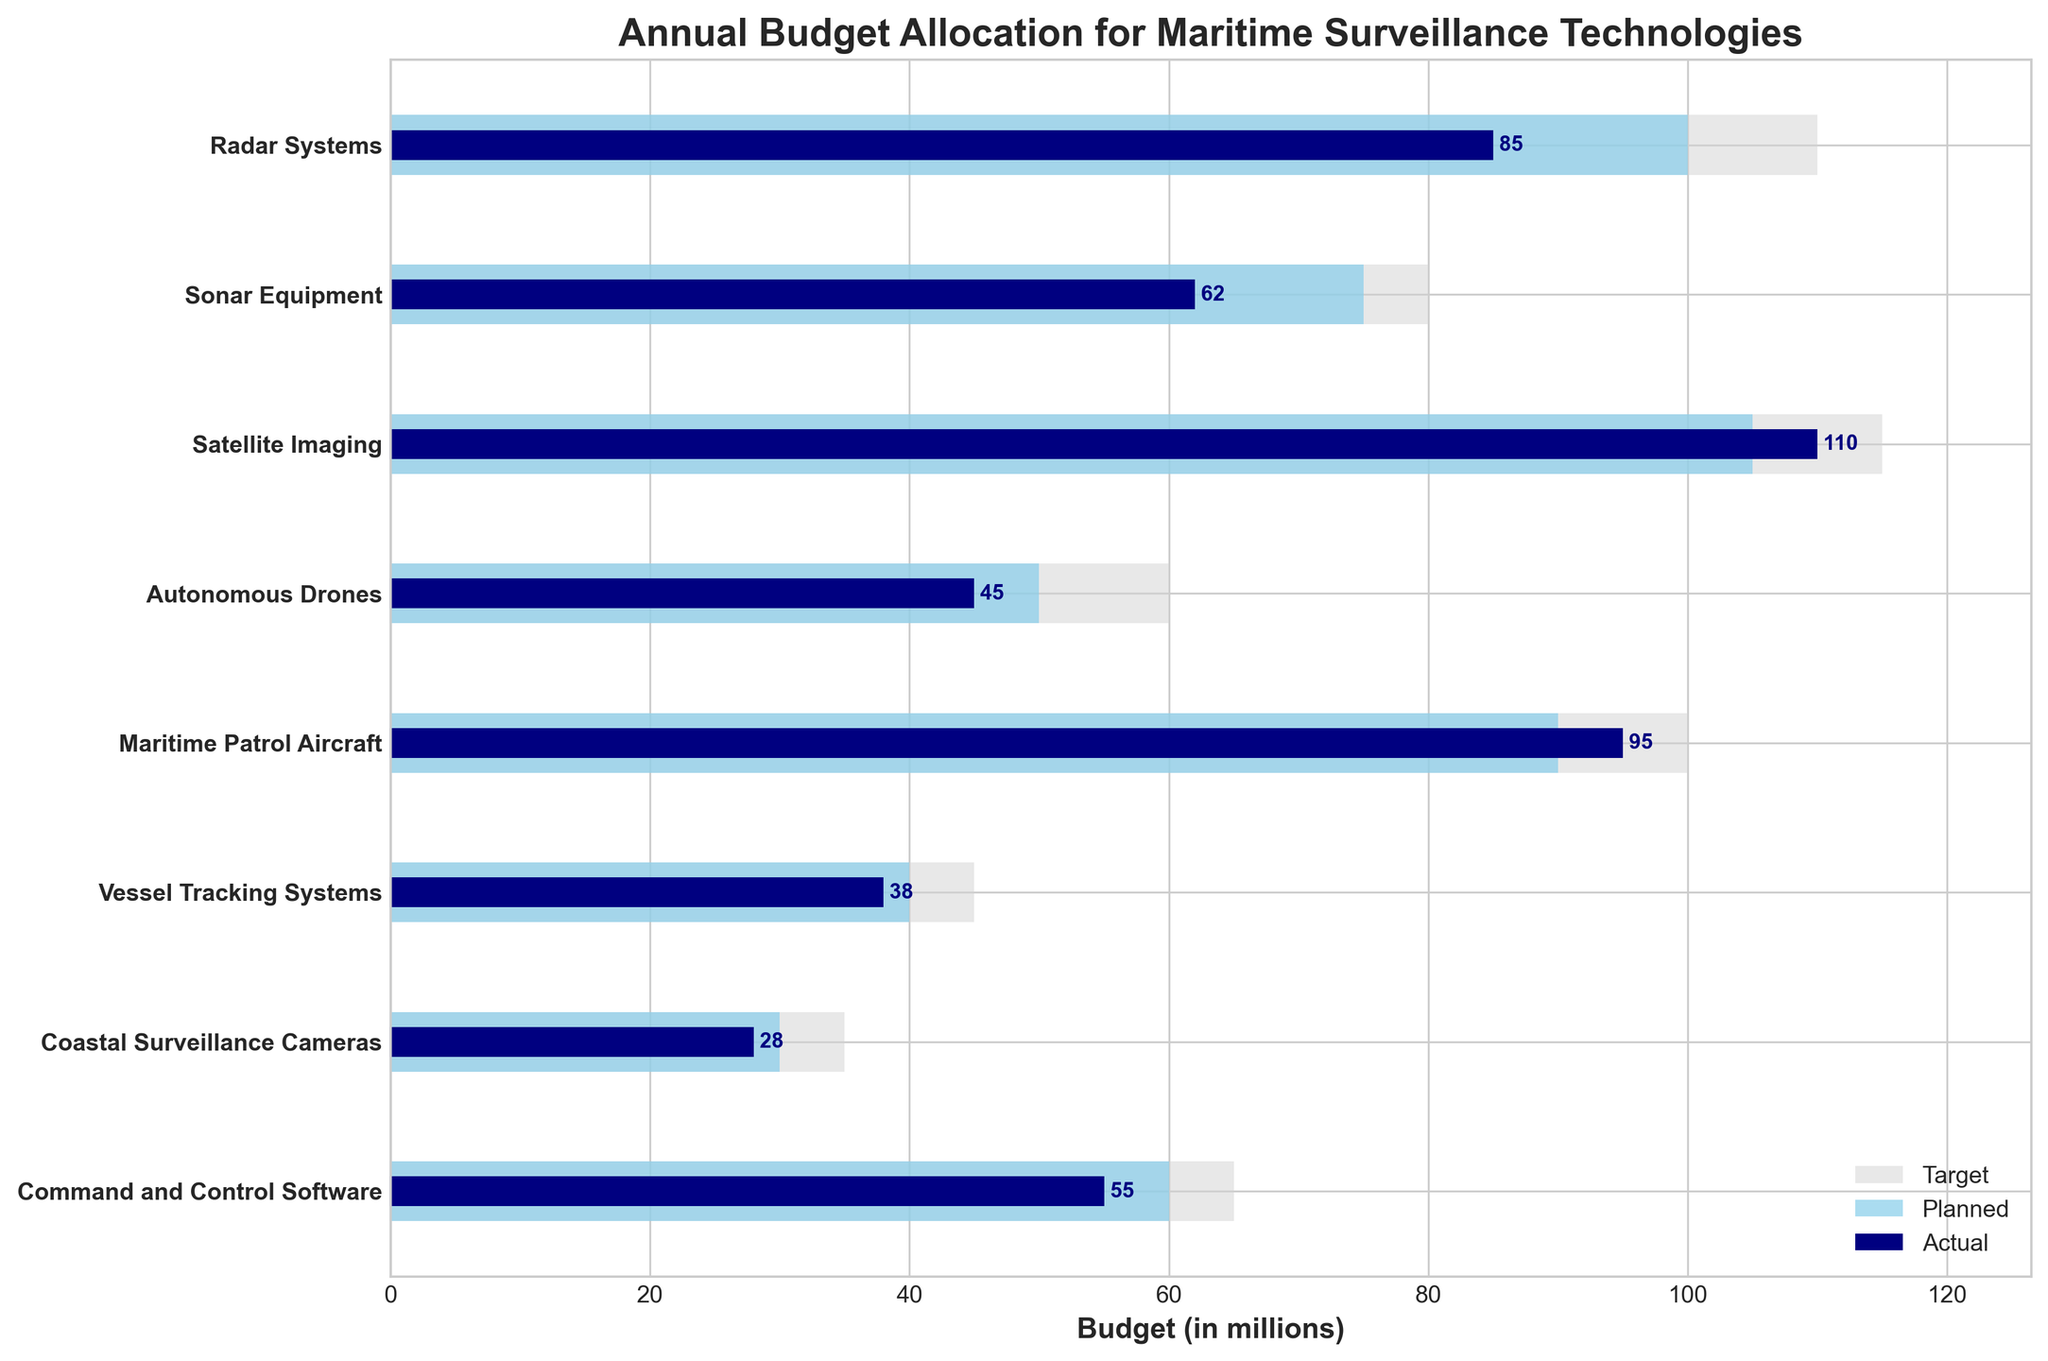What is the actual spending on Maritime Patrol Aircraft? The actual spending on Maritime Patrol Aircraft can be found by looking at the navy blue bar corresponding to that category.
Answer: 95 How does the actual spending on Radar Systems compare to its target spending? The actual spending on Radar Systems is 85, and the target spending is 110. To compare, subtract 85 from 110.
Answer: 25 million less Which category has the highest planned expenditure? The highest planned expenditure is indicated by the tallest sky-blue bar corresponding to a category. The Satellite Imaging category has the highest planned expenditure of 105.
Answer: Satellite Imaging Which category sees the largest gap between actual and planned spending? To determine the largest gap, we need to look at the difference between the navy blue and sky-blue bars for each category. Radar Systems has a gap of 15, Sonar Equipment has 13, among others, but the largest gap is in Autonomous Drones with a gap of 5.
Answer: Radar Systems What categories exceeded their planned spending based on actual spending? Categories that exceeded their planned spending will have a navy blue bar (actual spending) that extends beyond the sky-blue bar (planned spending). Satellite Imaging (110 vs. 105) and Maritime Patrol Aircraft (95 vs. 90) exceed their planned spending.
Answer: Satellite Imaging, Maritime Patrol Aircraft What is the combined actual spending on Command and Control Software and Vessel Tracking Systems? The actual spending on Command and Control Software is 55 and on Vessel Tracking Systems is 38. Combine them by adding 55 and 38.
Answer: 93 What is the target expenditure for Coastal Surveillance Cameras? The target expenditure for Coastal Surveillance Cameras can be found by looking at the length of the light grey bar corresponding to that category, which is 35.
Answer: 35 How does the planned expenditure for Sonar Equipment compare to the actual expenditure for Autonomous Drones? The planned expenditure for Sonar Equipment is 75, and the actual expenditure for Autonomous Drones is 45. Compare these values directly.
Answer: 30 million more Which category has the smallest actual spending? The smallest actual spending is represented by the shortest navy blue bar. Coastal Surveillance Cameras have the smallest actual spending of 28.
Answer: Coastal Surveillance Cameras What is the difference between the target and planned expenditure for Vessel Tracking Systems? The target expenditure for Vessel Tracking Systems is 45 and the planned expenditure is 40. Subtract 40 from 45 to find the difference.
Answer: 5 